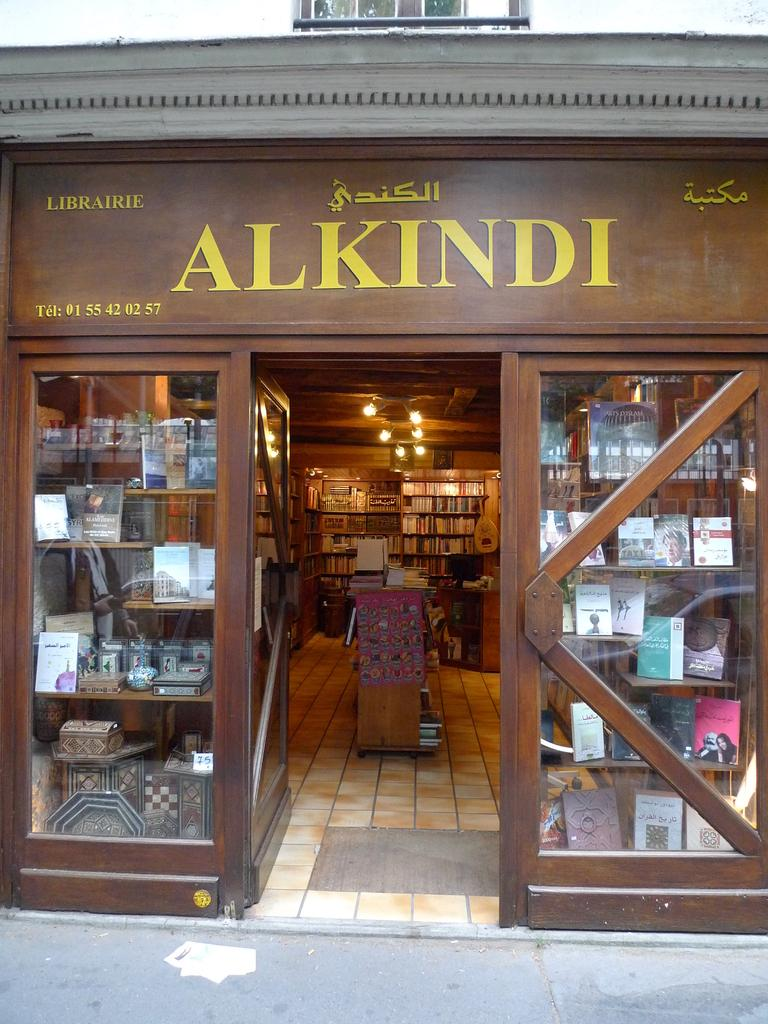Provide a one-sentence caption for the provided image. The front of a bookstore that is called Alkindi. 